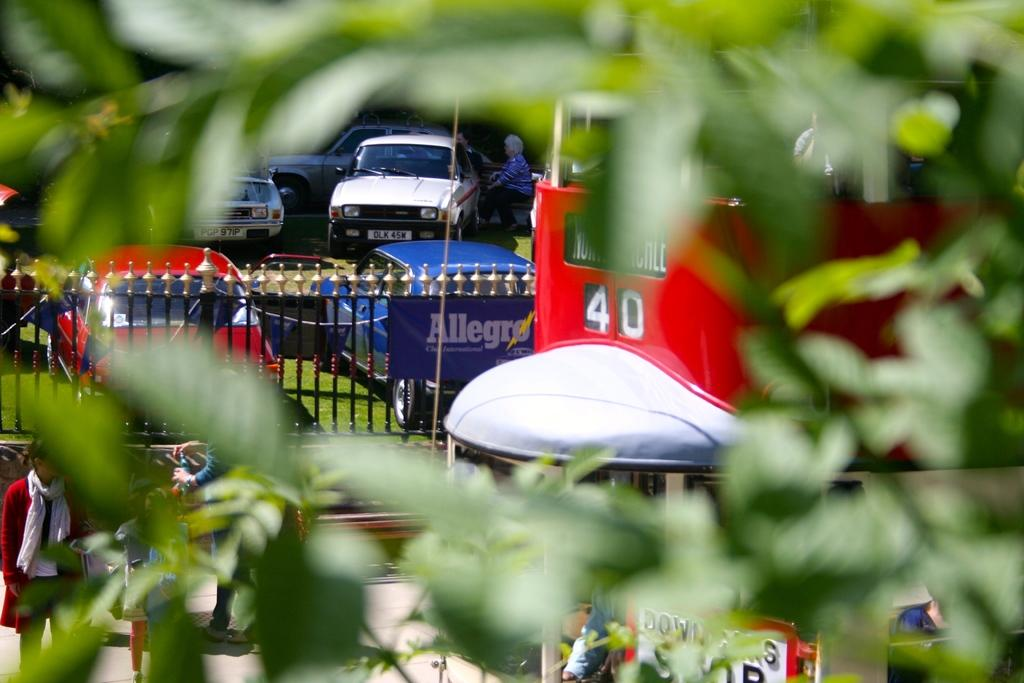What type of natural element is present in the image? There is a tree in the image. What are the people in the image doing? People are standing on the road in the image. What can be seen parked on the ground in the image? There are vehicles parked on the ground in the image. What type of surface is covered with grass in the image? The ground is covered with grass in the image. What type of office can be seen in the background of the image? There is no office present in the image; it features a tree, people standing on the road, parked vehicles, and grass-covered ground. How fast are the people running in the image? There is no indication that the people are running in the image; they are simply standing on the road. 